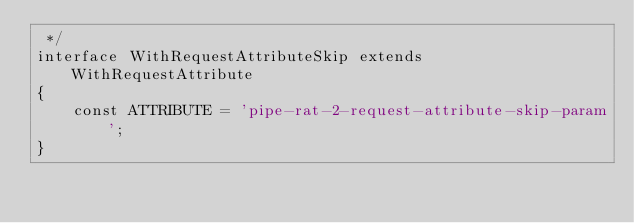Convert code to text. <code><loc_0><loc_0><loc_500><loc_500><_PHP_> */
interface WithRequestAttributeSkip extends WithRequestAttribute
{
    const ATTRIBUTE = 'pipe-rat-2-request-attribute-skip-param';
}
</code> 